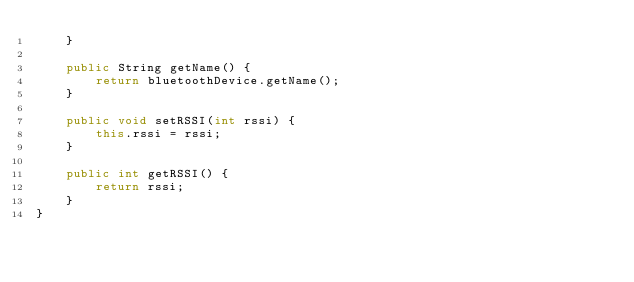Convert code to text. <code><loc_0><loc_0><loc_500><loc_500><_Java_>    }

    public String getName() {
        return bluetoothDevice.getName();
    }

    public void setRSSI(int rssi) {
        this.rssi = rssi;
    }

    public int getRSSI() {
        return rssi;
    }
}</code> 